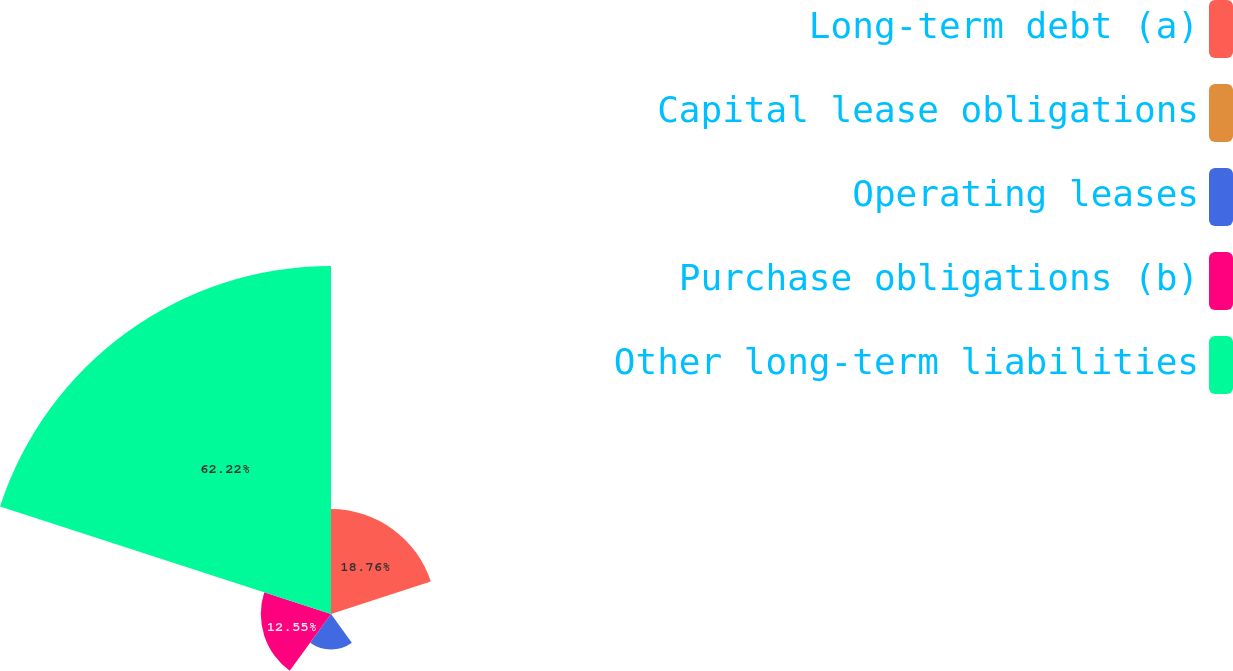<chart> <loc_0><loc_0><loc_500><loc_500><pie_chart><fcel>Long-term debt (a)<fcel>Capital lease obligations<fcel>Operating leases<fcel>Purchase obligations (b)<fcel>Other long-term liabilities<nl><fcel>18.76%<fcel>0.13%<fcel>6.34%<fcel>12.55%<fcel>62.23%<nl></chart> 